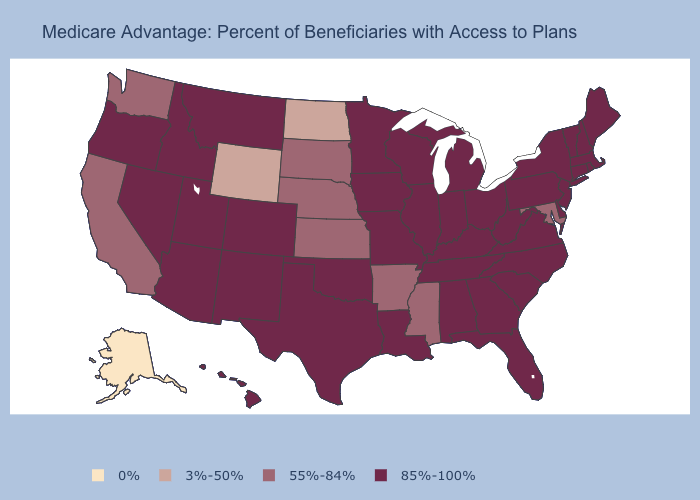How many symbols are there in the legend?
Short answer required. 4. Among the states that border Alabama , does Mississippi have the lowest value?
Give a very brief answer. Yes. What is the value of Indiana?
Keep it brief. 85%-100%. What is the value of Vermont?
Answer briefly. 85%-100%. Which states have the highest value in the USA?
Write a very short answer. Alabama, Arizona, Colorado, Connecticut, Delaware, Florida, Georgia, Hawaii, Idaho, Illinois, Indiana, Iowa, Kentucky, Louisiana, Maine, Massachusetts, Michigan, Minnesota, Missouri, Montana, Nevada, New Hampshire, New Jersey, New Mexico, New York, North Carolina, Ohio, Oklahoma, Oregon, Pennsylvania, Rhode Island, South Carolina, Tennessee, Texas, Utah, Vermont, Virginia, West Virginia, Wisconsin. Among the states that border Louisiana , does Texas have the lowest value?
Give a very brief answer. No. What is the value of Mississippi?
Quick response, please. 55%-84%. Among the states that border Iowa , does Nebraska have the highest value?
Write a very short answer. No. What is the highest value in states that border Connecticut?
Concise answer only. 85%-100%. Does the map have missing data?
Be succinct. No. Name the states that have a value in the range 0%?
Concise answer only. Alaska. Is the legend a continuous bar?
Short answer required. No. What is the lowest value in the USA?
Keep it brief. 0%. What is the value of Nevada?
Concise answer only. 85%-100%. 